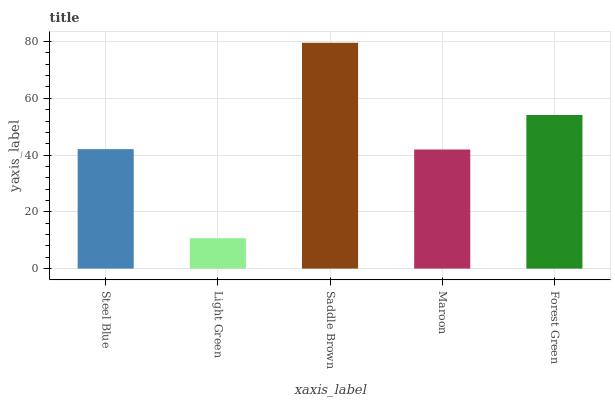Is Light Green the minimum?
Answer yes or no. Yes. Is Saddle Brown the maximum?
Answer yes or no. Yes. Is Saddle Brown the minimum?
Answer yes or no. No. Is Light Green the maximum?
Answer yes or no. No. Is Saddle Brown greater than Light Green?
Answer yes or no. Yes. Is Light Green less than Saddle Brown?
Answer yes or no. Yes. Is Light Green greater than Saddle Brown?
Answer yes or no. No. Is Saddle Brown less than Light Green?
Answer yes or no. No. Is Steel Blue the high median?
Answer yes or no. Yes. Is Steel Blue the low median?
Answer yes or no. Yes. Is Forest Green the high median?
Answer yes or no. No. Is Forest Green the low median?
Answer yes or no. No. 